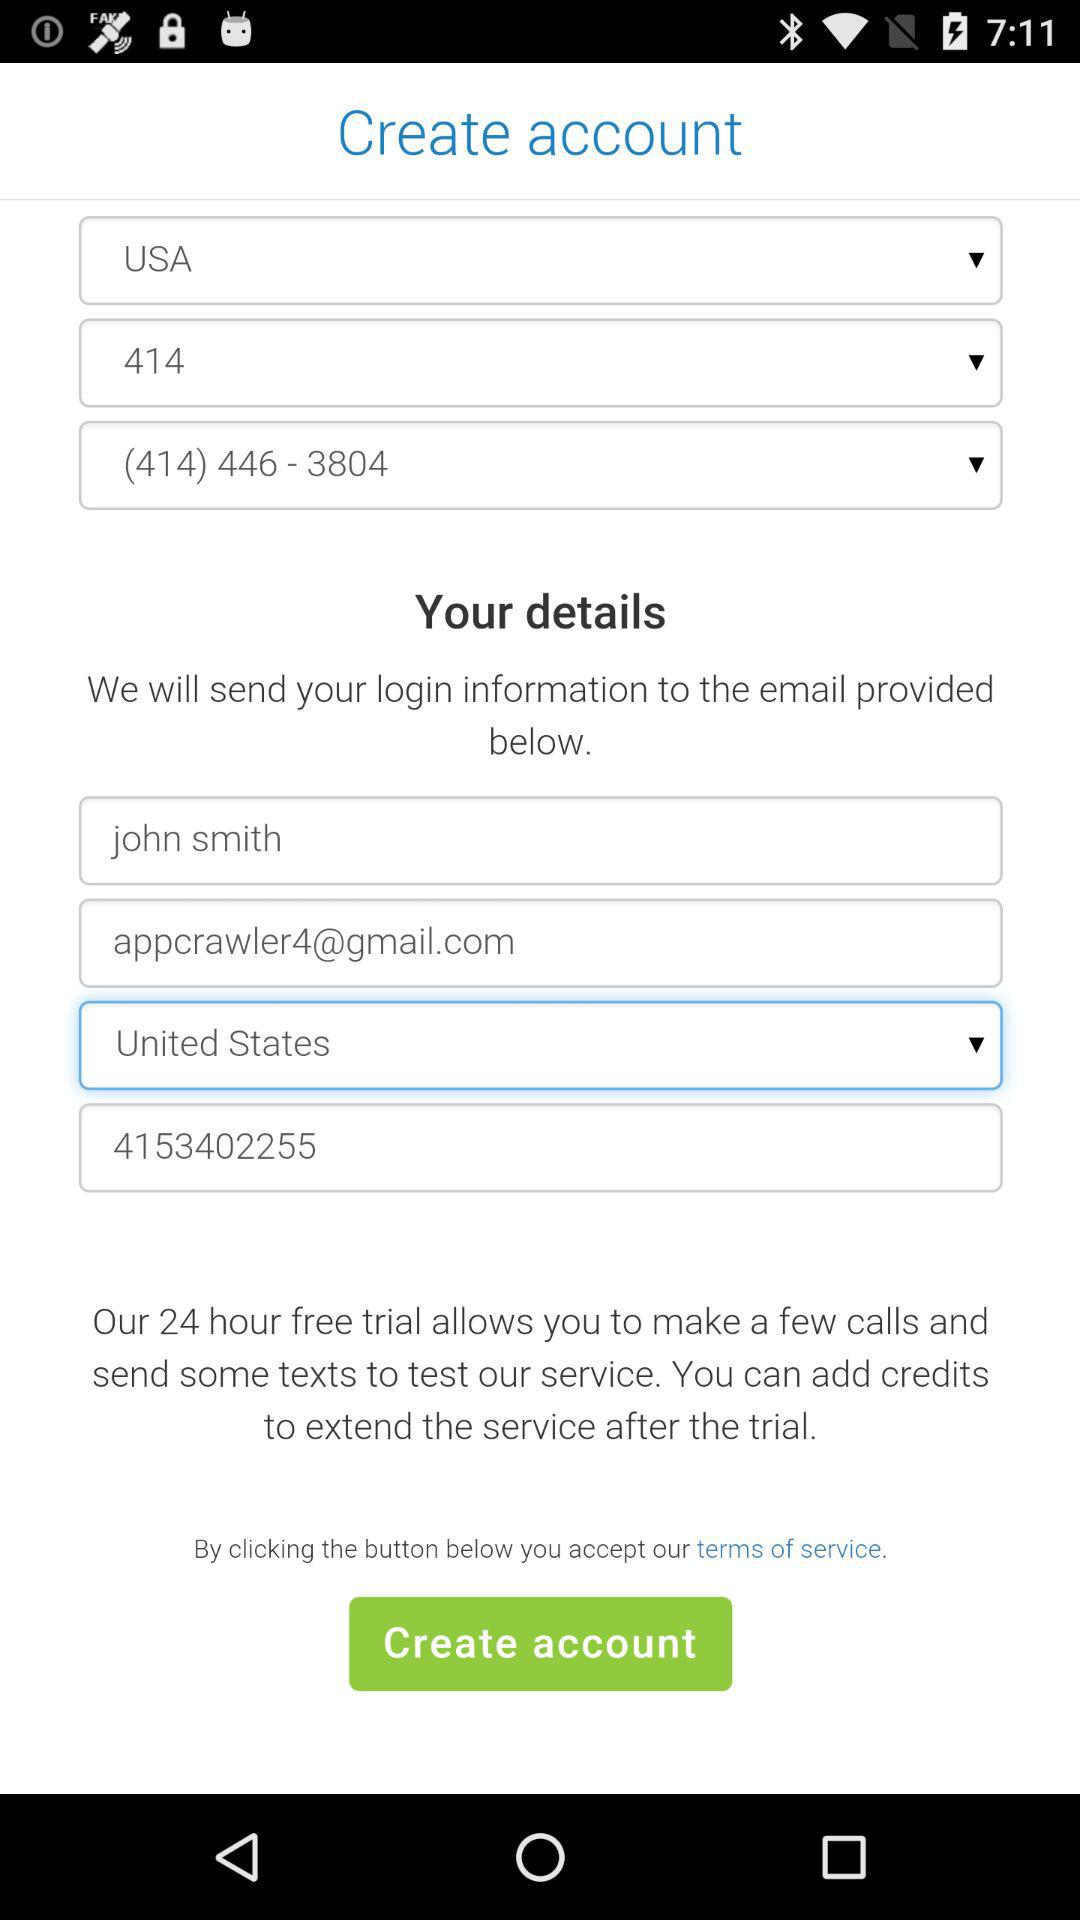What is the email address? The email address is appcrawler4@gmail.com. 